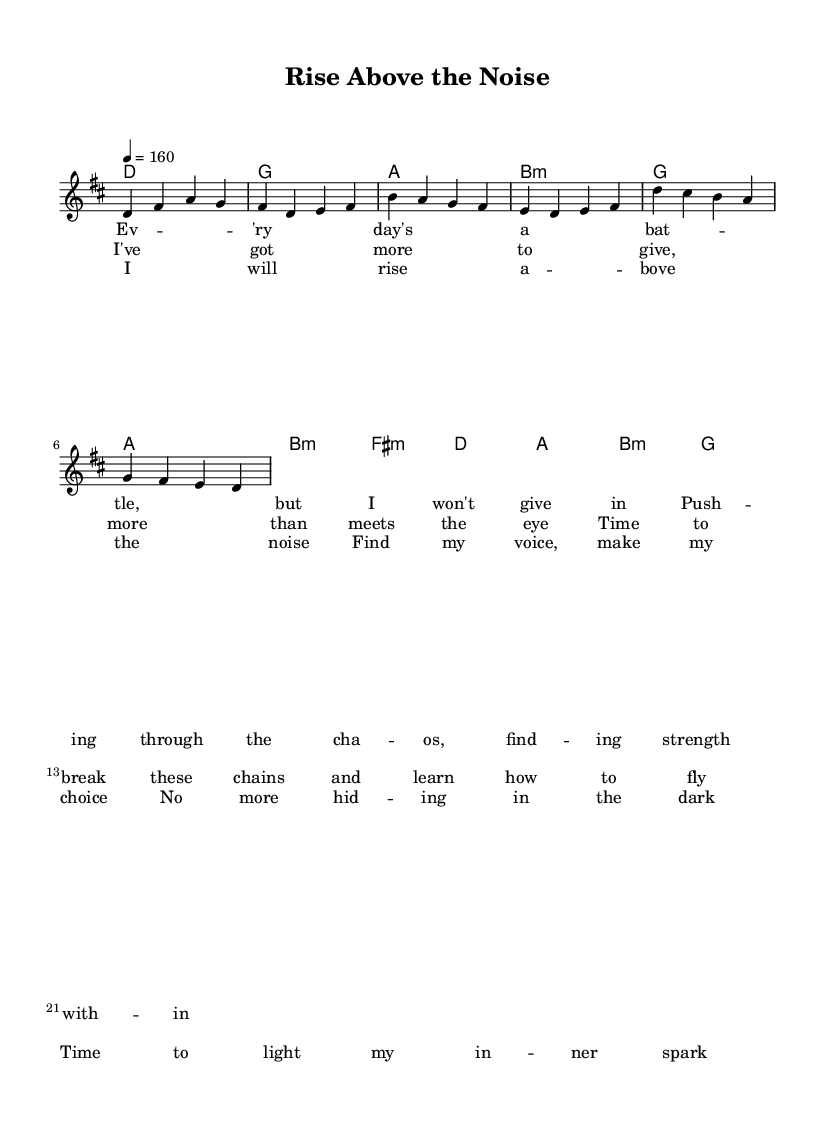What is the key signature of this music? The key signature shown in the music indicates D major, which has two sharps (F# and C#).
Answer: D major What is the time signature of this piece? The time signature in the music indicates 4/4, which means there are four beats in each measure and a quarter note gets one beat.
Answer: 4/4 What is the tempo marking for this piece? The tempo is marked as 4 = 160, which indicates that there are 160 beats per minute, giving the piece a fast-paced feel.
Answer: 160 What is the first chord in the verse section? The first chord in the verse is D major, as indicated in the chord names section above the melody line.
Answer: D How many measures are there in the chorus section? The chorus contains four measures, as indicated by the grouping of notes and the chord changes.
Answer: 4 What is the emotional theme expressed in the lyrics of the chorus? The chorus expresses themes of empowerment and self-discovery, emphasizing rising above challenges and finding inner strength.
Answer: Empowerment In which part of the song does the line "I've got more to give, more than meets the eye" appear? This line appears in the pre-chorus section, indicating a transition toward a more uplifting and positive message.
Answer: Pre-Chorus 